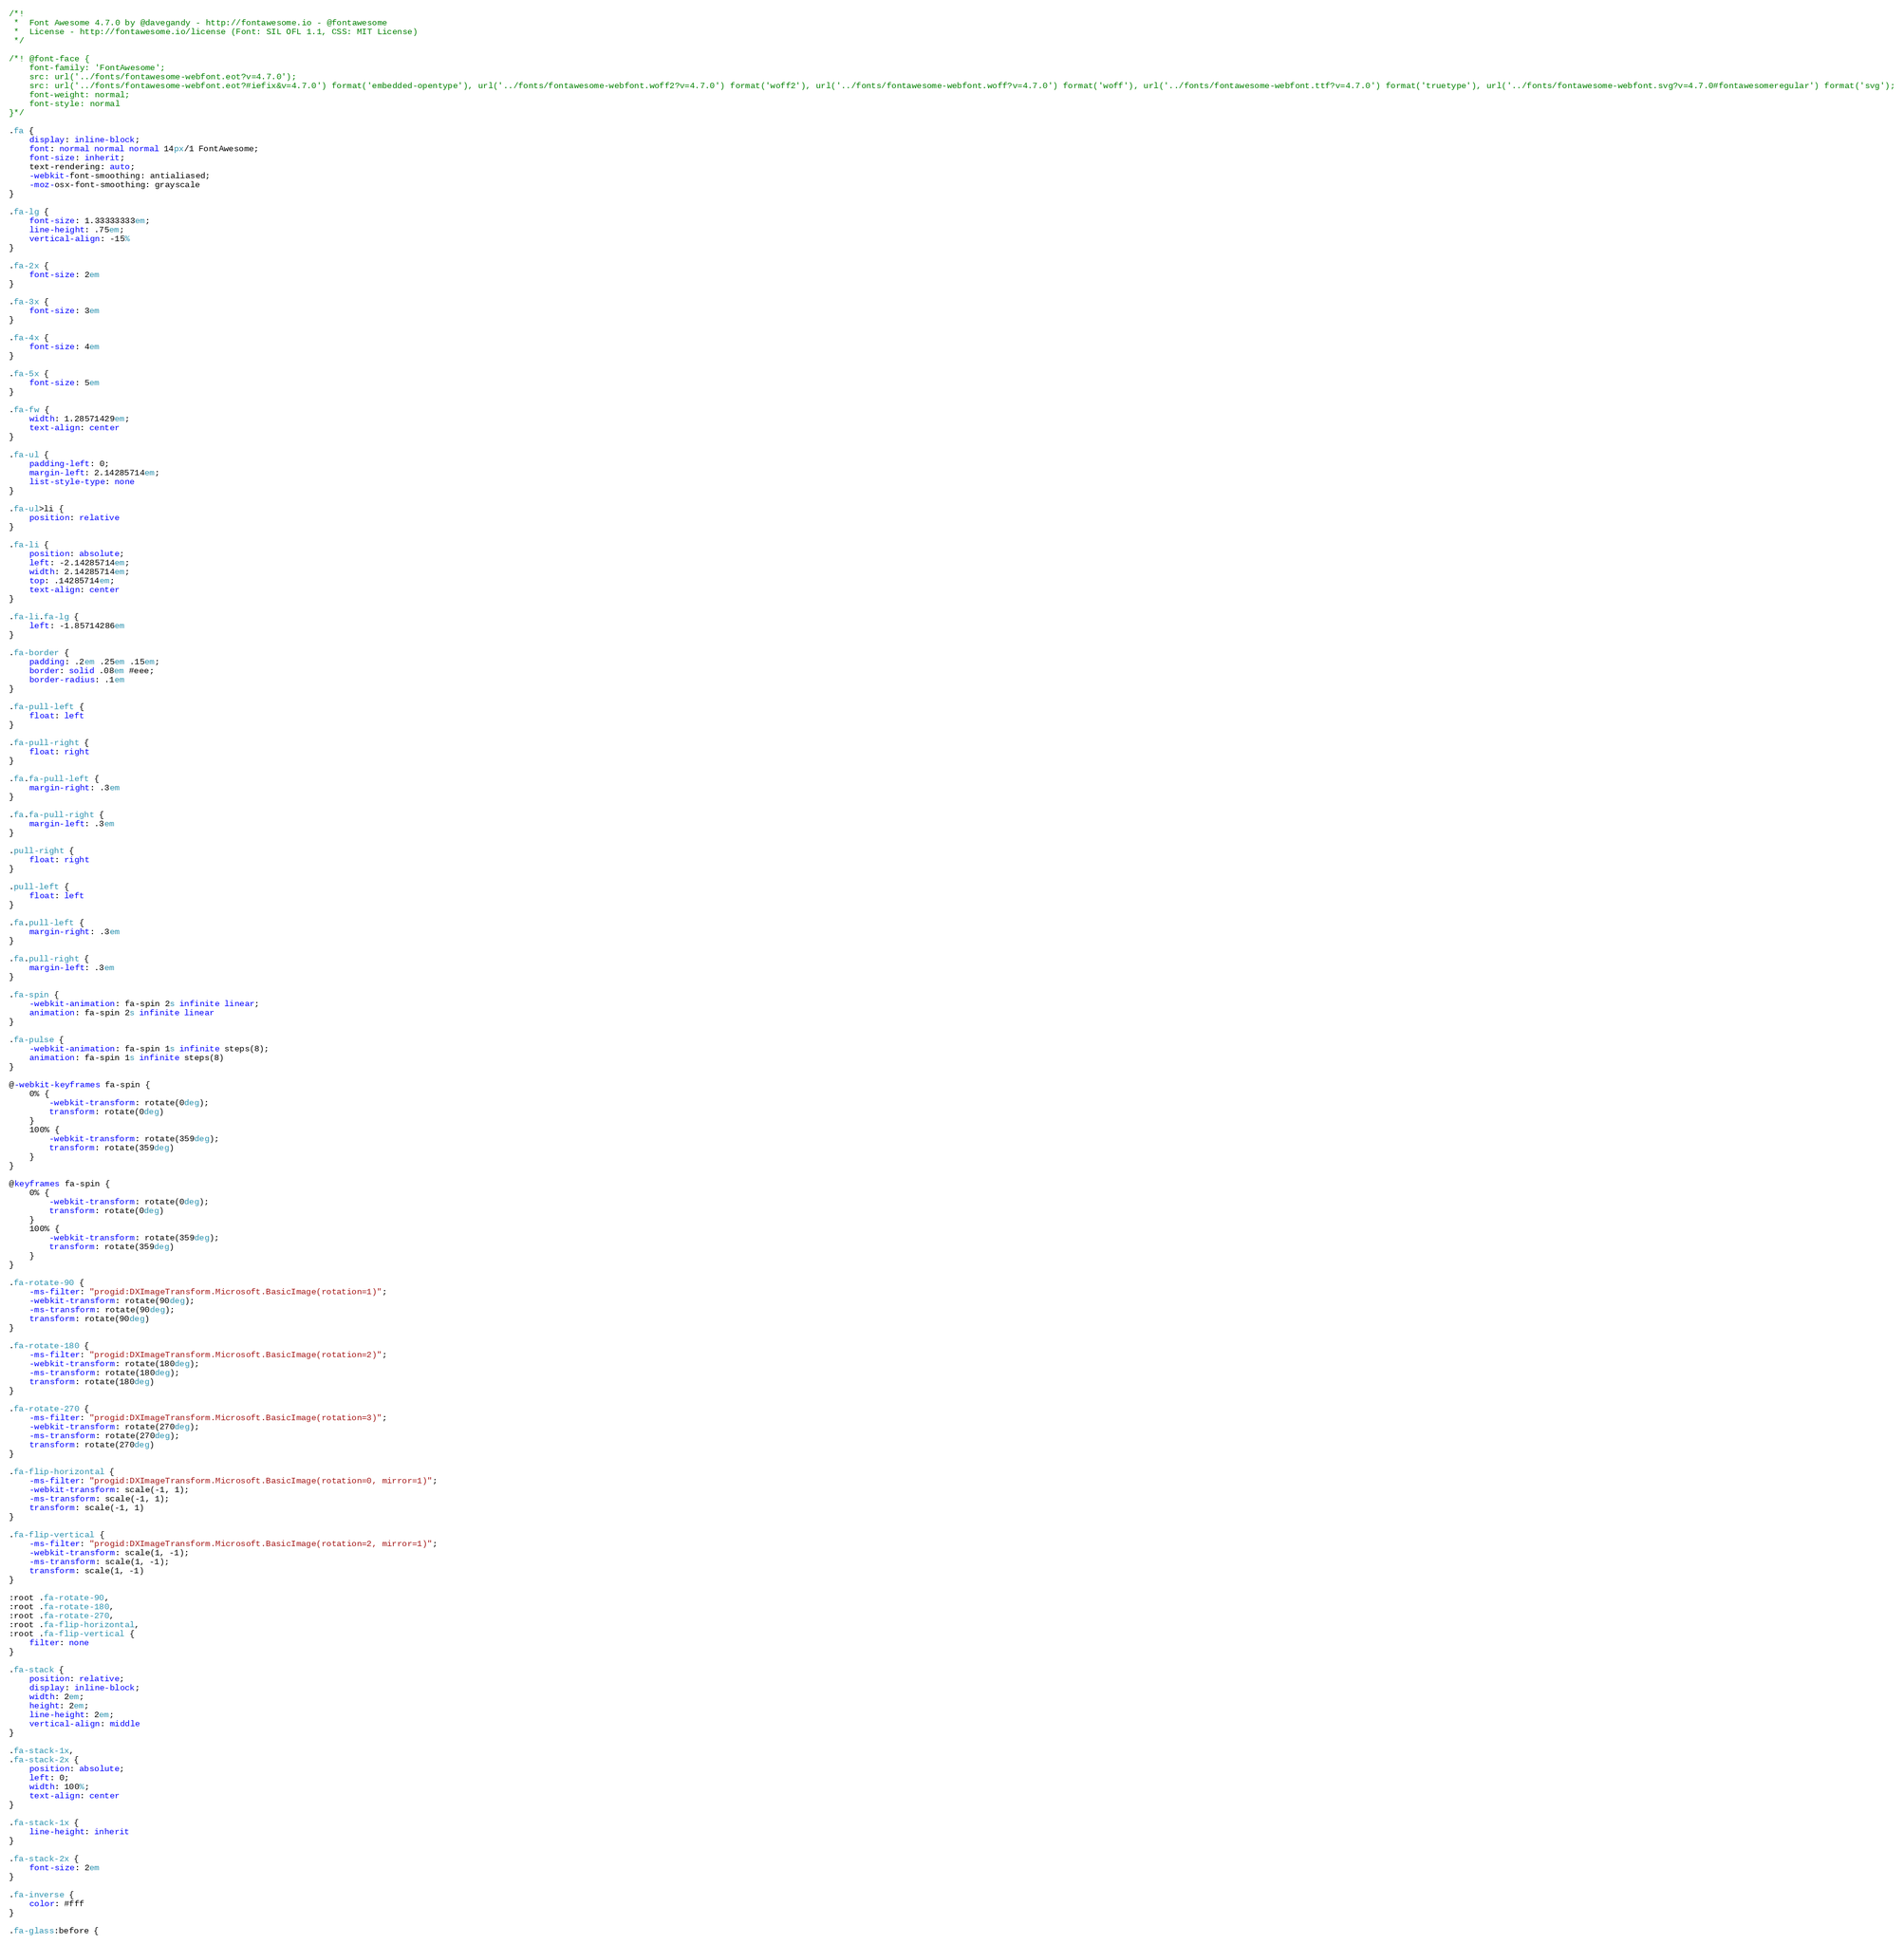<code> <loc_0><loc_0><loc_500><loc_500><_CSS_>/*!
 *  Font Awesome 4.7.0 by @davegandy - http://fontawesome.io - @fontawesome
 *  License - http://fontawesome.io/license (Font: SIL OFL 1.1, CSS: MIT License)
 */

/*! @font-face {
    font-family: 'FontAwesome';
    src: url('../fonts/fontawesome-webfont.eot?v=4.7.0');
    src: url('../fonts/fontawesome-webfont.eot?#iefix&v=4.7.0') format('embedded-opentype'), url('../fonts/fontawesome-webfont.woff2?v=4.7.0') format('woff2'), url('../fonts/fontawesome-webfont.woff?v=4.7.0') format('woff'), url('../fonts/fontawesome-webfont.ttf?v=4.7.0') format('truetype'), url('../fonts/fontawesome-webfont.svg?v=4.7.0#fontawesomeregular') format('svg');
    font-weight: normal;
    font-style: normal
}*/

.fa {
    display: inline-block;
    font: normal normal normal 14px/1 FontAwesome;
    font-size: inherit;
    text-rendering: auto;
    -webkit-font-smoothing: antialiased;
    -moz-osx-font-smoothing: grayscale
}

.fa-lg {
    font-size: 1.33333333em;
    line-height: .75em;
    vertical-align: -15%
}

.fa-2x {
    font-size: 2em
}

.fa-3x {
    font-size: 3em
}

.fa-4x {
    font-size: 4em
}

.fa-5x {
    font-size: 5em
}

.fa-fw {
    width: 1.28571429em;
    text-align: center
}

.fa-ul {
    padding-left: 0;
    margin-left: 2.14285714em;
    list-style-type: none
}

.fa-ul>li {
    position: relative
}

.fa-li {
    position: absolute;
    left: -2.14285714em;
    width: 2.14285714em;
    top: .14285714em;
    text-align: center
}

.fa-li.fa-lg {
    left: -1.85714286em
}

.fa-border {
    padding: .2em .25em .15em;
    border: solid .08em #eee;
    border-radius: .1em
}

.fa-pull-left {
    float: left
}

.fa-pull-right {
    float: right
}

.fa.fa-pull-left {
    margin-right: .3em
}

.fa.fa-pull-right {
    margin-left: .3em
}

.pull-right {
    float: right
}

.pull-left {
    float: left
}

.fa.pull-left {
    margin-right: .3em
}

.fa.pull-right {
    margin-left: .3em
}

.fa-spin {
    -webkit-animation: fa-spin 2s infinite linear;
    animation: fa-spin 2s infinite linear
}

.fa-pulse {
    -webkit-animation: fa-spin 1s infinite steps(8);
    animation: fa-spin 1s infinite steps(8)
}

@-webkit-keyframes fa-spin {
    0% {
        -webkit-transform: rotate(0deg);
        transform: rotate(0deg)
    }
    100% {
        -webkit-transform: rotate(359deg);
        transform: rotate(359deg)
    }
}

@keyframes fa-spin {
    0% {
        -webkit-transform: rotate(0deg);
        transform: rotate(0deg)
    }
    100% {
        -webkit-transform: rotate(359deg);
        transform: rotate(359deg)
    }
}

.fa-rotate-90 {
    -ms-filter: "progid:DXImageTransform.Microsoft.BasicImage(rotation=1)";
    -webkit-transform: rotate(90deg);
    -ms-transform: rotate(90deg);
    transform: rotate(90deg)
}

.fa-rotate-180 {
    -ms-filter: "progid:DXImageTransform.Microsoft.BasicImage(rotation=2)";
    -webkit-transform: rotate(180deg);
    -ms-transform: rotate(180deg);
    transform: rotate(180deg)
}

.fa-rotate-270 {
    -ms-filter: "progid:DXImageTransform.Microsoft.BasicImage(rotation=3)";
    -webkit-transform: rotate(270deg);
    -ms-transform: rotate(270deg);
    transform: rotate(270deg)
}

.fa-flip-horizontal {
    -ms-filter: "progid:DXImageTransform.Microsoft.BasicImage(rotation=0, mirror=1)";
    -webkit-transform: scale(-1, 1);
    -ms-transform: scale(-1, 1);
    transform: scale(-1, 1)
}

.fa-flip-vertical {
    -ms-filter: "progid:DXImageTransform.Microsoft.BasicImage(rotation=2, mirror=1)";
    -webkit-transform: scale(1, -1);
    -ms-transform: scale(1, -1);
    transform: scale(1, -1)
}

:root .fa-rotate-90,
:root .fa-rotate-180,
:root .fa-rotate-270,
:root .fa-flip-horizontal,
:root .fa-flip-vertical {
    filter: none
}

.fa-stack {
    position: relative;
    display: inline-block;
    width: 2em;
    height: 2em;
    line-height: 2em;
    vertical-align: middle
}

.fa-stack-1x,
.fa-stack-2x {
    position: absolute;
    left: 0;
    width: 100%;
    text-align: center
}

.fa-stack-1x {
    line-height: inherit
}

.fa-stack-2x {
    font-size: 2em
}

.fa-inverse {
    color: #fff
}

.fa-glass:before {</code> 